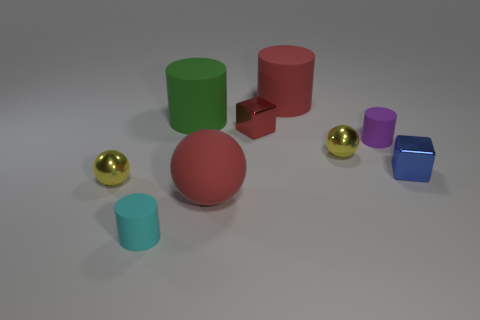Subtract 1 cylinders. How many cylinders are left? 3 Add 1 brown cylinders. How many objects exist? 10 Subtract all blocks. How many objects are left? 7 Subtract all green shiny blocks. Subtract all large green rubber cylinders. How many objects are left? 8 Add 9 small red cubes. How many small red cubes are left? 10 Add 2 large yellow shiny objects. How many large yellow shiny objects exist? 2 Subtract 0 brown cubes. How many objects are left? 9 